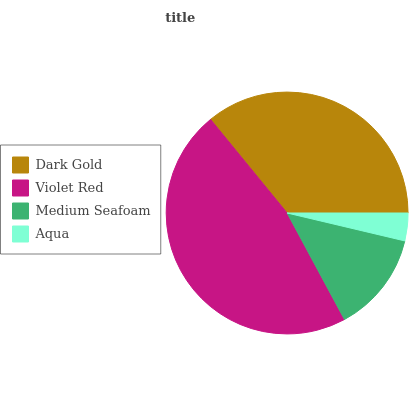Is Aqua the minimum?
Answer yes or no. Yes. Is Violet Red the maximum?
Answer yes or no. Yes. Is Medium Seafoam the minimum?
Answer yes or no. No. Is Medium Seafoam the maximum?
Answer yes or no. No. Is Violet Red greater than Medium Seafoam?
Answer yes or no. Yes. Is Medium Seafoam less than Violet Red?
Answer yes or no. Yes. Is Medium Seafoam greater than Violet Red?
Answer yes or no. No. Is Violet Red less than Medium Seafoam?
Answer yes or no. No. Is Dark Gold the high median?
Answer yes or no. Yes. Is Medium Seafoam the low median?
Answer yes or no. Yes. Is Aqua the high median?
Answer yes or no. No. Is Aqua the low median?
Answer yes or no. No. 